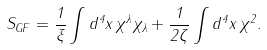<formula> <loc_0><loc_0><loc_500><loc_500>S _ { G F } = \frac { 1 } { \xi } \int d ^ { 4 } x \, \chi ^ { \lambda } \chi _ { \lambda } + \frac { 1 } { 2 \zeta } \int d ^ { 4 } x \, \chi ^ { 2 } .</formula> 